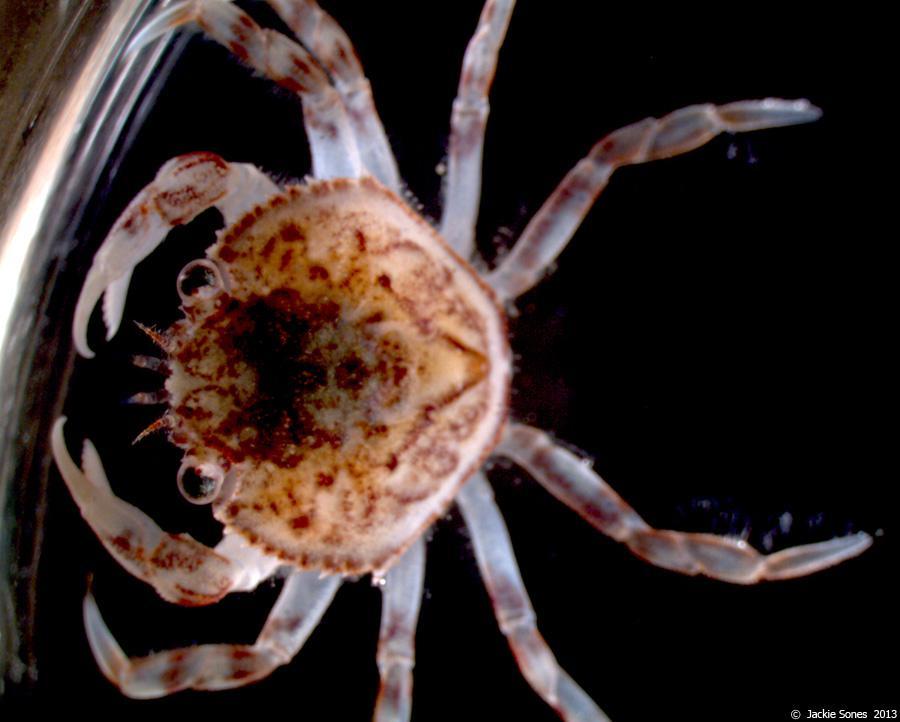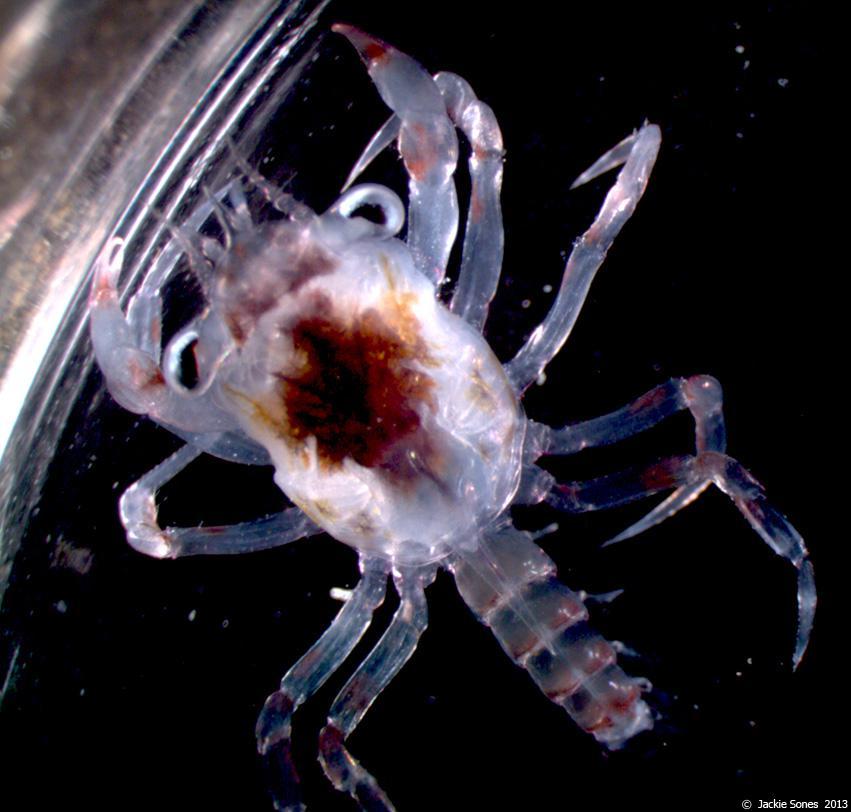The first image is the image on the left, the second image is the image on the right. Examine the images to the left and right. Is the description "Each image contains one many-legged creature, but the creatures depicted on the left and right do not have the same body shape and are not facing in the same direction." accurate? Answer yes or no. Yes. The first image is the image on the left, the second image is the image on the right. For the images displayed, is the sentence "Two pairs of pincers are visible." factually correct? Answer yes or no. Yes. 